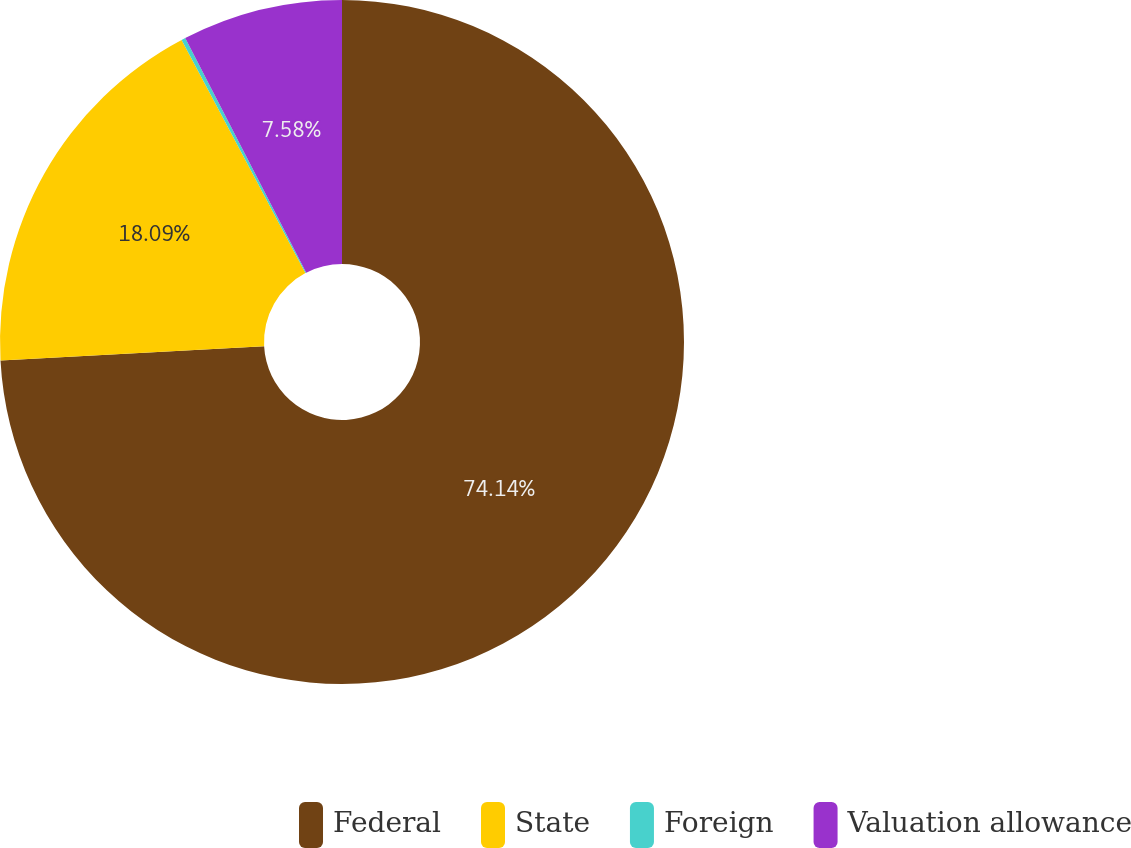Convert chart. <chart><loc_0><loc_0><loc_500><loc_500><pie_chart><fcel>Federal<fcel>State<fcel>Foreign<fcel>Valuation allowance<nl><fcel>74.14%<fcel>18.09%<fcel>0.19%<fcel>7.58%<nl></chart> 